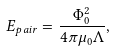<formula> <loc_0><loc_0><loc_500><loc_500>E _ { p a i r } = \frac { \Phi _ { 0 } ^ { 2 } } { 4 \pi \mu _ { 0 } \Lambda } ,</formula> 